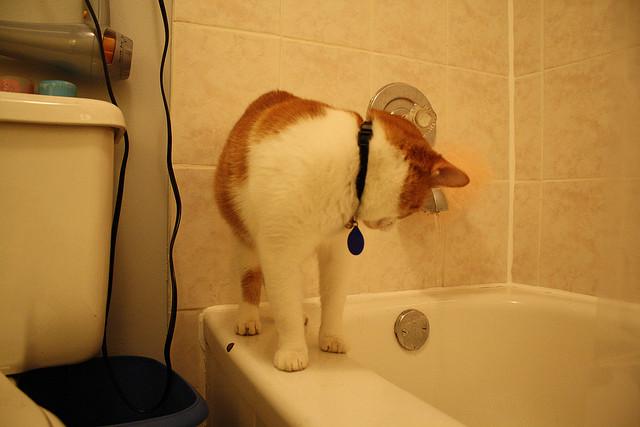Is the faucet turned on?
Keep it brief. Yes. What color is the cat's collar?
Answer briefly. Black. What is this cat standing on?
Short answer required. Bathtub. What is in the picture?
Quick response, please. Cat. Is the cat getting wet?
Short answer required. No. What is the lightest color of fur appearing on the cat?
Answer briefly. White. Is this cat drinking from the dripping water?
Write a very short answer. No. 